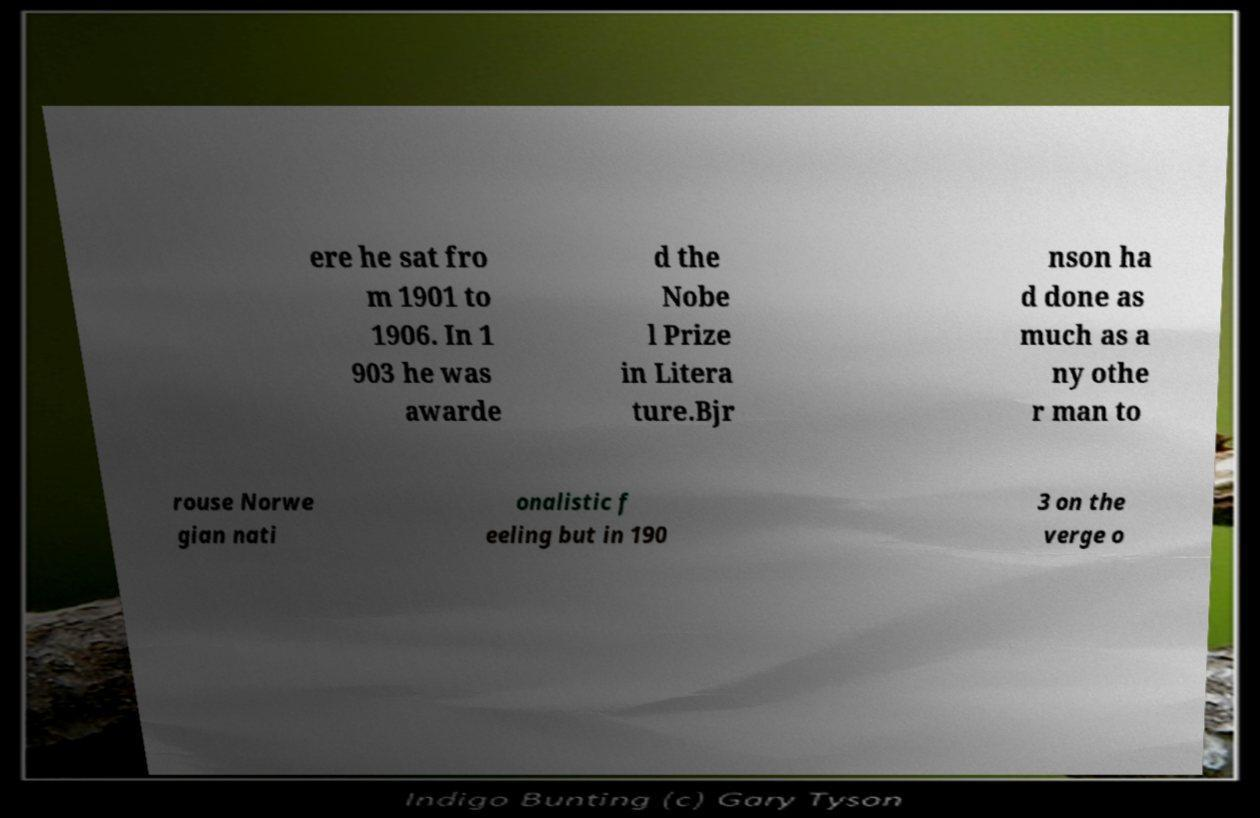Could you extract and type out the text from this image? ere he sat fro m 1901 to 1906. In 1 903 he was awarde d the Nobe l Prize in Litera ture.Bjr nson ha d done as much as a ny othe r man to rouse Norwe gian nati onalistic f eeling but in 190 3 on the verge o 